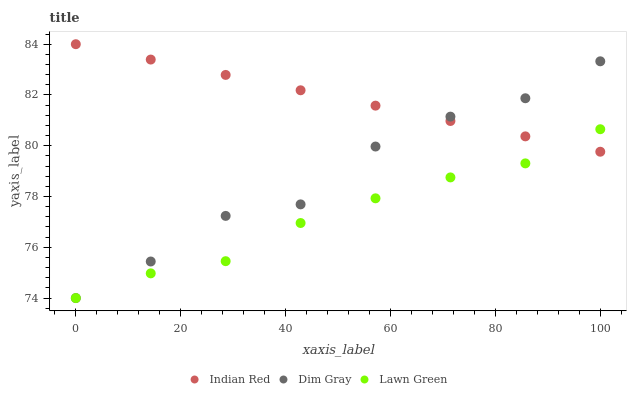Does Lawn Green have the minimum area under the curve?
Answer yes or no. Yes. Does Indian Red have the maximum area under the curve?
Answer yes or no. Yes. Does Dim Gray have the minimum area under the curve?
Answer yes or no. No. Does Dim Gray have the maximum area under the curve?
Answer yes or no. No. Is Indian Red the smoothest?
Answer yes or no. Yes. Is Dim Gray the roughest?
Answer yes or no. Yes. Is Dim Gray the smoothest?
Answer yes or no. No. Is Indian Red the roughest?
Answer yes or no. No. Does Lawn Green have the lowest value?
Answer yes or no. Yes. Does Indian Red have the lowest value?
Answer yes or no. No. Does Indian Red have the highest value?
Answer yes or no. Yes. Does Dim Gray have the highest value?
Answer yes or no. No. Does Lawn Green intersect Indian Red?
Answer yes or no. Yes. Is Lawn Green less than Indian Red?
Answer yes or no. No. Is Lawn Green greater than Indian Red?
Answer yes or no. No. 